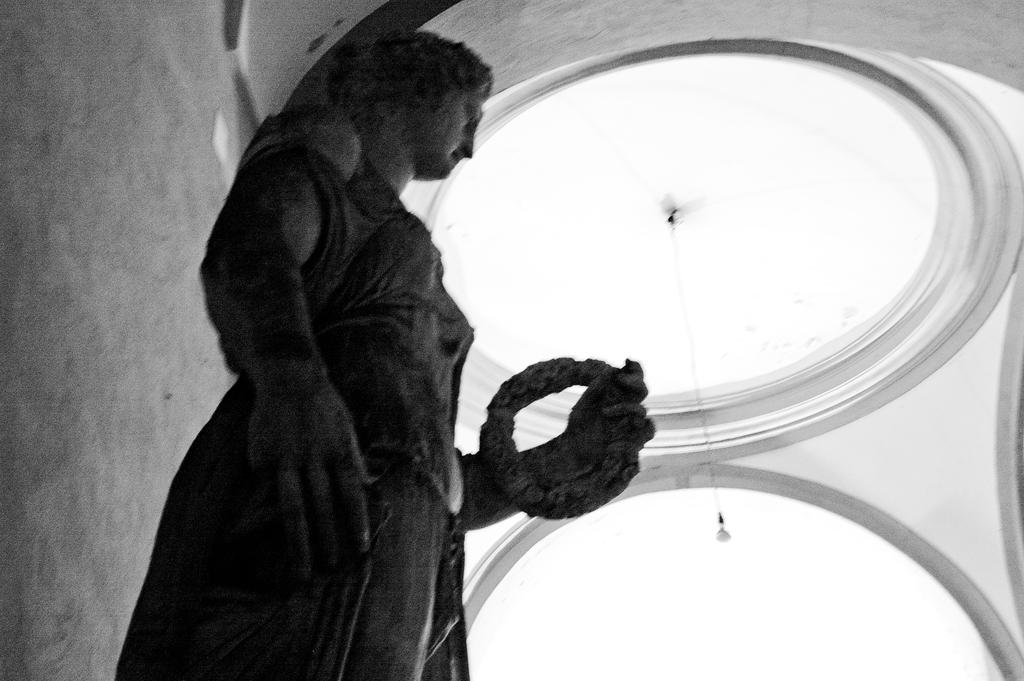What is the main subject in the front of the image? There is a statue in the front of the image. What can be seen in the background of the image? There is a light hanging and a wall in the background of the image. How many ducks are sitting on the statue in the image? There are no ducks present in the image; it features a statue and a light hanging in the background. 